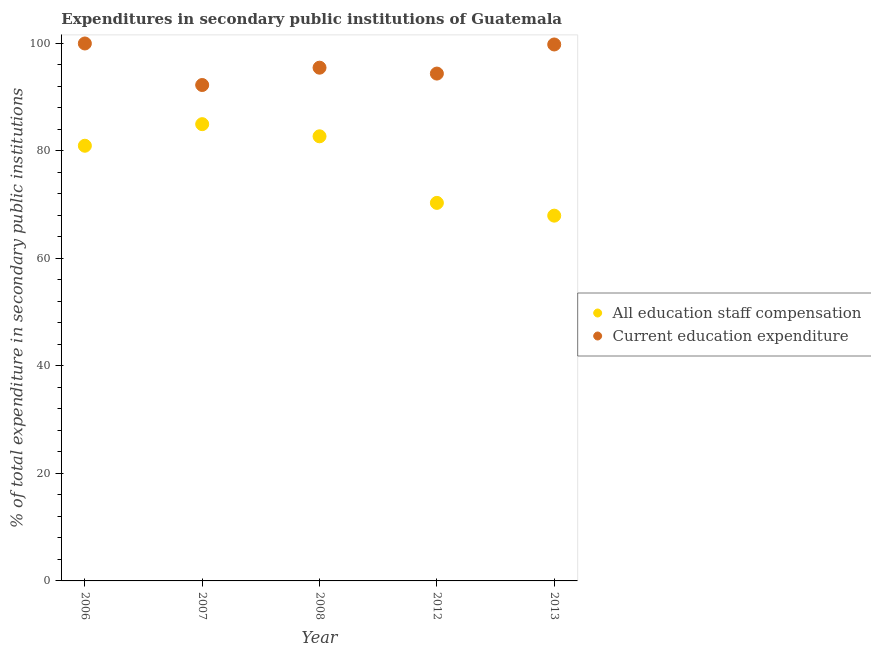How many different coloured dotlines are there?
Provide a short and direct response. 2. What is the expenditure in staff compensation in 2008?
Give a very brief answer. 82.73. Across all years, what is the maximum expenditure in staff compensation?
Your response must be concise. 84.99. Across all years, what is the minimum expenditure in education?
Offer a very short reply. 92.27. What is the total expenditure in education in the graph?
Provide a succinct answer. 481.99. What is the difference between the expenditure in staff compensation in 2006 and that in 2008?
Provide a short and direct response. -1.76. What is the difference between the expenditure in staff compensation in 2012 and the expenditure in education in 2008?
Ensure brevity in your answer.  -25.16. What is the average expenditure in education per year?
Your response must be concise. 96.4. In the year 2006, what is the difference between the expenditure in staff compensation and expenditure in education?
Your response must be concise. -19.03. What is the ratio of the expenditure in education in 2012 to that in 2013?
Give a very brief answer. 0.95. What is the difference between the highest and the second highest expenditure in staff compensation?
Your answer should be compact. 2.26. What is the difference between the highest and the lowest expenditure in staff compensation?
Offer a very short reply. 17.02. In how many years, is the expenditure in staff compensation greater than the average expenditure in staff compensation taken over all years?
Ensure brevity in your answer.  3. Does the expenditure in staff compensation monotonically increase over the years?
Your answer should be compact. No. Is the expenditure in education strictly less than the expenditure in staff compensation over the years?
Ensure brevity in your answer.  No. Does the graph contain any zero values?
Offer a terse response. No. Where does the legend appear in the graph?
Make the answer very short. Center right. How are the legend labels stacked?
Provide a short and direct response. Vertical. What is the title of the graph?
Provide a succinct answer. Expenditures in secondary public institutions of Guatemala. What is the label or title of the X-axis?
Ensure brevity in your answer.  Year. What is the label or title of the Y-axis?
Your response must be concise. % of total expenditure in secondary public institutions. What is the % of total expenditure in secondary public institutions in All education staff compensation in 2006?
Ensure brevity in your answer.  80.97. What is the % of total expenditure in secondary public institutions in All education staff compensation in 2007?
Keep it short and to the point. 84.99. What is the % of total expenditure in secondary public institutions in Current education expenditure in 2007?
Make the answer very short. 92.27. What is the % of total expenditure in secondary public institutions of All education staff compensation in 2008?
Provide a short and direct response. 82.73. What is the % of total expenditure in secondary public institutions of Current education expenditure in 2008?
Give a very brief answer. 95.5. What is the % of total expenditure in secondary public institutions in All education staff compensation in 2012?
Offer a very short reply. 70.34. What is the % of total expenditure in secondary public institutions in Current education expenditure in 2012?
Your response must be concise. 94.4. What is the % of total expenditure in secondary public institutions in All education staff compensation in 2013?
Provide a short and direct response. 67.96. What is the % of total expenditure in secondary public institutions in Current education expenditure in 2013?
Keep it short and to the point. 99.82. Across all years, what is the maximum % of total expenditure in secondary public institutions in All education staff compensation?
Make the answer very short. 84.99. Across all years, what is the maximum % of total expenditure in secondary public institutions of Current education expenditure?
Provide a short and direct response. 100. Across all years, what is the minimum % of total expenditure in secondary public institutions in All education staff compensation?
Give a very brief answer. 67.96. Across all years, what is the minimum % of total expenditure in secondary public institutions in Current education expenditure?
Provide a succinct answer. 92.27. What is the total % of total expenditure in secondary public institutions of All education staff compensation in the graph?
Offer a terse response. 387. What is the total % of total expenditure in secondary public institutions of Current education expenditure in the graph?
Offer a terse response. 481.99. What is the difference between the % of total expenditure in secondary public institutions of All education staff compensation in 2006 and that in 2007?
Provide a short and direct response. -4.02. What is the difference between the % of total expenditure in secondary public institutions of Current education expenditure in 2006 and that in 2007?
Your response must be concise. 7.73. What is the difference between the % of total expenditure in secondary public institutions of All education staff compensation in 2006 and that in 2008?
Your answer should be very brief. -1.76. What is the difference between the % of total expenditure in secondary public institutions of Current education expenditure in 2006 and that in 2008?
Provide a succinct answer. 4.5. What is the difference between the % of total expenditure in secondary public institutions in All education staff compensation in 2006 and that in 2012?
Give a very brief answer. 10.63. What is the difference between the % of total expenditure in secondary public institutions in Current education expenditure in 2006 and that in 2012?
Offer a very short reply. 5.6. What is the difference between the % of total expenditure in secondary public institutions in All education staff compensation in 2006 and that in 2013?
Keep it short and to the point. 13.01. What is the difference between the % of total expenditure in secondary public institutions of Current education expenditure in 2006 and that in 2013?
Ensure brevity in your answer.  0.18. What is the difference between the % of total expenditure in secondary public institutions of All education staff compensation in 2007 and that in 2008?
Make the answer very short. 2.26. What is the difference between the % of total expenditure in secondary public institutions in Current education expenditure in 2007 and that in 2008?
Keep it short and to the point. -3.22. What is the difference between the % of total expenditure in secondary public institutions in All education staff compensation in 2007 and that in 2012?
Offer a very short reply. 14.65. What is the difference between the % of total expenditure in secondary public institutions of Current education expenditure in 2007 and that in 2012?
Provide a short and direct response. -2.13. What is the difference between the % of total expenditure in secondary public institutions in All education staff compensation in 2007 and that in 2013?
Your response must be concise. 17.02. What is the difference between the % of total expenditure in secondary public institutions in Current education expenditure in 2007 and that in 2013?
Provide a succinct answer. -7.54. What is the difference between the % of total expenditure in secondary public institutions in All education staff compensation in 2008 and that in 2012?
Provide a succinct answer. 12.39. What is the difference between the % of total expenditure in secondary public institutions in Current education expenditure in 2008 and that in 2012?
Your answer should be very brief. 1.1. What is the difference between the % of total expenditure in secondary public institutions in All education staff compensation in 2008 and that in 2013?
Your answer should be very brief. 14.76. What is the difference between the % of total expenditure in secondary public institutions of Current education expenditure in 2008 and that in 2013?
Provide a succinct answer. -4.32. What is the difference between the % of total expenditure in secondary public institutions of All education staff compensation in 2012 and that in 2013?
Provide a succinct answer. 2.38. What is the difference between the % of total expenditure in secondary public institutions in Current education expenditure in 2012 and that in 2013?
Provide a succinct answer. -5.42. What is the difference between the % of total expenditure in secondary public institutions in All education staff compensation in 2006 and the % of total expenditure in secondary public institutions in Current education expenditure in 2007?
Offer a very short reply. -11.3. What is the difference between the % of total expenditure in secondary public institutions of All education staff compensation in 2006 and the % of total expenditure in secondary public institutions of Current education expenditure in 2008?
Your response must be concise. -14.52. What is the difference between the % of total expenditure in secondary public institutions in All education staff compensation in 2006 and the % of total expenditure in secondary public institutions in Current education expenditure in 2012?
Your response must be concise. -13.43. What is the difference between the % of total expenditure in secondary public institutions in All education staff compensation in 2006 and the % of total expenditure in secondary public institutions in Current education expenditure in 2013?
Make the answer very short. -18.84. What is the difference between the % of total expenditure in secondary public institutions of All education staff compensation in 2007 and the % of total expenditure in secondary public institutions of Current education expenditure in 2008?
Give a very brief answer. -10.51. What is the difference between the % of total expenditure in secondary public institutions of All education staff compensation in 2007 and the % of total expenditure in secondary public institutions of Current education expenditure in 2012?
Provide a succinct answer. -9.41. What is the difference between the % of total expenditure in secondary public institutions in All education staff compensation in 2007 and the % of total expenditure in secondary public institutions in Current education expenditure in 2013?
Your answer should be very brief. -14.83. What is the difference between the % of total expenditure in secondary public institutions in All education staff compensation in 2008 and the % of total expenditure in secondary public institutions in Current education expenditure in 2012?
Your answer should be very brief. -11.67. What is the difference between the % of total expenditure in secondary public institutions of All education staff compensation in 2008 and the % of total expenditure in secondary public institutions of Current education expenditure in 2013?
Keep it short and to the point. -17.09. What is the difference between the % of total expenditure in secondary public institutions in All education staff compensation in 2012 and the % of total expenditure in secondary public institutions in Current education expenditure in 2013?
Give a very brief answer. -29.48. What is the average % of total expenditure in secondary public institutions of All education staff compensation per year?
Make the answer very short. 77.4. What is the average % of total expenditure in secondary public institutions in Current education expenditure per year?
Provide a short and direct response. 96.4. In the year 2006, what is the difference between the % of total expenditure in secondary public institutions in All education staff compensation and % of total expenditure in secondary public institutions in Current education expenditure?
Your response must be concise. -19.03. In the year 2007, what is the difference between the % of total expenditure in secondary public institutions in All education staff compensation and % of total expenditure in secondary public institutions in Current education expenditure?
Offer a very short reply. -7.28. In the year 2008, what is the difference between the % of total expenditure in secondary public institutions in All education staff compensation and % of total expenditure in secondary public institutions in Current education expenditure?
Offer a very short reply. -12.77. In the year 2012, what is the difference between the % of total expenditure in secondary public institutions of All education staff compensation and % of total expenditure in secondary public institutions of Current education expenditure?
Ensure brevity in your answer.  -24.06. In the year 2013, what is the difference between the % of total expenditure in secondary public institutions in All education staff compensation and % of total expenditure in secondary public institutions in Current education expenditure?
Your response must be concise. -31.85. What is the ratio of the % of total expenditure in secondary public institutions of All education staff compensation in 2006 to that in 2007?
Your response must be concise. 0.95. What is the ratio of the % of total expenditure in secondary public institutions of Current education expenditure in 2006 to that in 2007?
Offer a terse response. 1.08. What is the ratio of the % of total expenditure in secondary public institutions of All education staff compensation in 2006 to that in 2008?
Your response must be concise. 0.98. What is the ratio of the % of total expenditure in secondary public institutions in Current education expenditure in 2006 to that in 2008?
Give a very brief answer. 1.05. What is the ratio of the % of total expenditure in secondary public institutions of All education staff compensation in 2006 to that in 2012?
Make the answer very short. 1.15. What is the ratio of the % of total expenditure in secondary public institutions of Current education expenditure in 2006 to that in 2012?
Your answer should be compact. 1.06. What is the ratio of the % of total expenditure in secondary public institutions of All education staff compensation in 2006 to that in 2013?
Ensure brevity in your answer.  1.19. What is the ratio of the % of total expenditure in secondary public institutions of Current education expenditure in 2006 to that in 2013?
Your answer should be compact. 1. What is the ratio of the % of total expenditure in secondary public institutions in All education staff compensation in 2007 to that in 2008?
Offer a terse response. 1.03. What is the ratio of the % of total expenditure in secondary public institutions of Current education expenditure in 2007 to that in 2008?
Make the answer very short. 0.97. What is the ratio of the % of total expenditure in secondary public institutions of All education staff compensation in 2007 to that in 2012?
Provide a succinct answer. 1.21. What is the ratio of the % of total expenditure in secondary public institutions in Current education expenditure in 2007 to that in 2012?
Ensure brevity in your answer.  0.98. What is the ratio of the % of total expenditure in secondary public institutions in All education staff compensation in 2007 to that in 2013?
Make the answer very short. 1.25. What is the ratio of the % of total expenditure in secondary public institutions of Current education expenditure in 2007 to that in 2013?
Provide a succinct answer. 0.92. What is the ratio of the % of total expenditure in secondary public institutions of All education staff compensation in 2008 to that in 2012?
Offer a terse response. 1.18. What is the ratio of the % of total expenditure in secondary public institutions in Current education expenditure in 2008 to that in 2012?
Give a very brief answer. 1.01. What is the ratio of the % of total expenditure in secondary public institutions in All education staff compensation in 2008 to that in 2013?
Ensure brevity in your answer.  1.22. What is the ratio of the % of total expenditure in secondary public institutions in Current education expenditure in 2008 to that in 2013?
Give a very brief answer. 0.96. What is the ratio of the % of total expenditure in secondary public institutions of All education staff compensation in 2012 to that in 2013?
Offer a very short reply. 1.03. What is the ratio of the % of total expenditure in secondary public institutions in Current education expenditure in 2012 to that in 2013?
Your answer should be very brief. 0.95. What is the difference between the highest and the second highest % of total expenditure in secondary public institutions of All education staff compensation?
Offer a terse response. 2.26. What is the difference between the highest and the second highest % of total expenditure in secondary public institutions in Current education expenditure?
Give a very brief answer. 0.18. What is the difference between the highest and the lowest % of total expenditure in secondary public institutions of All education staff compensation?
Your response must be concise. 17.02. What is the difference between the highest and the lowest % of total expenditure in secondary public institutions of Current education expenditure?
Offer a terse response. 7.73. 